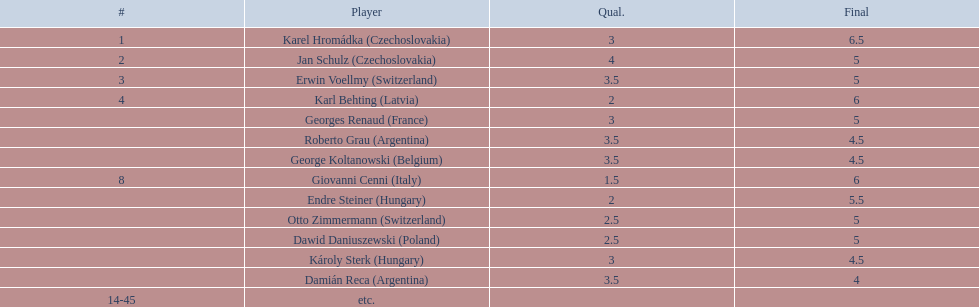Karl behting and giovanni cenni each had final scores of what? 6. 